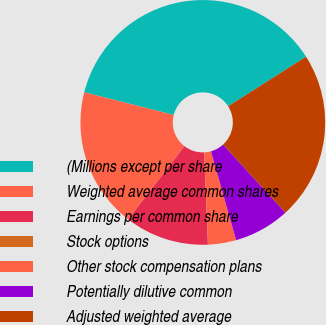Convert chart to OTSL. <chart><loc_0><loc_0><loc_500><loc_500><pie_chart><fcel>(Millions except per share<fcel>Weighted average common shares<fcel>Earnings per common share<fcel>Stock options<fcel>Other stock compensation plans<fcel>Potentially dilutive common<fcel>Adjusted weighted average<nl><fcel>37.02%<fcel>18.52%<fcel>11.11%<fcel>0.01%<fcel>3.71%<fcel>7.41%<fcel>22.22%<nl></chart> 